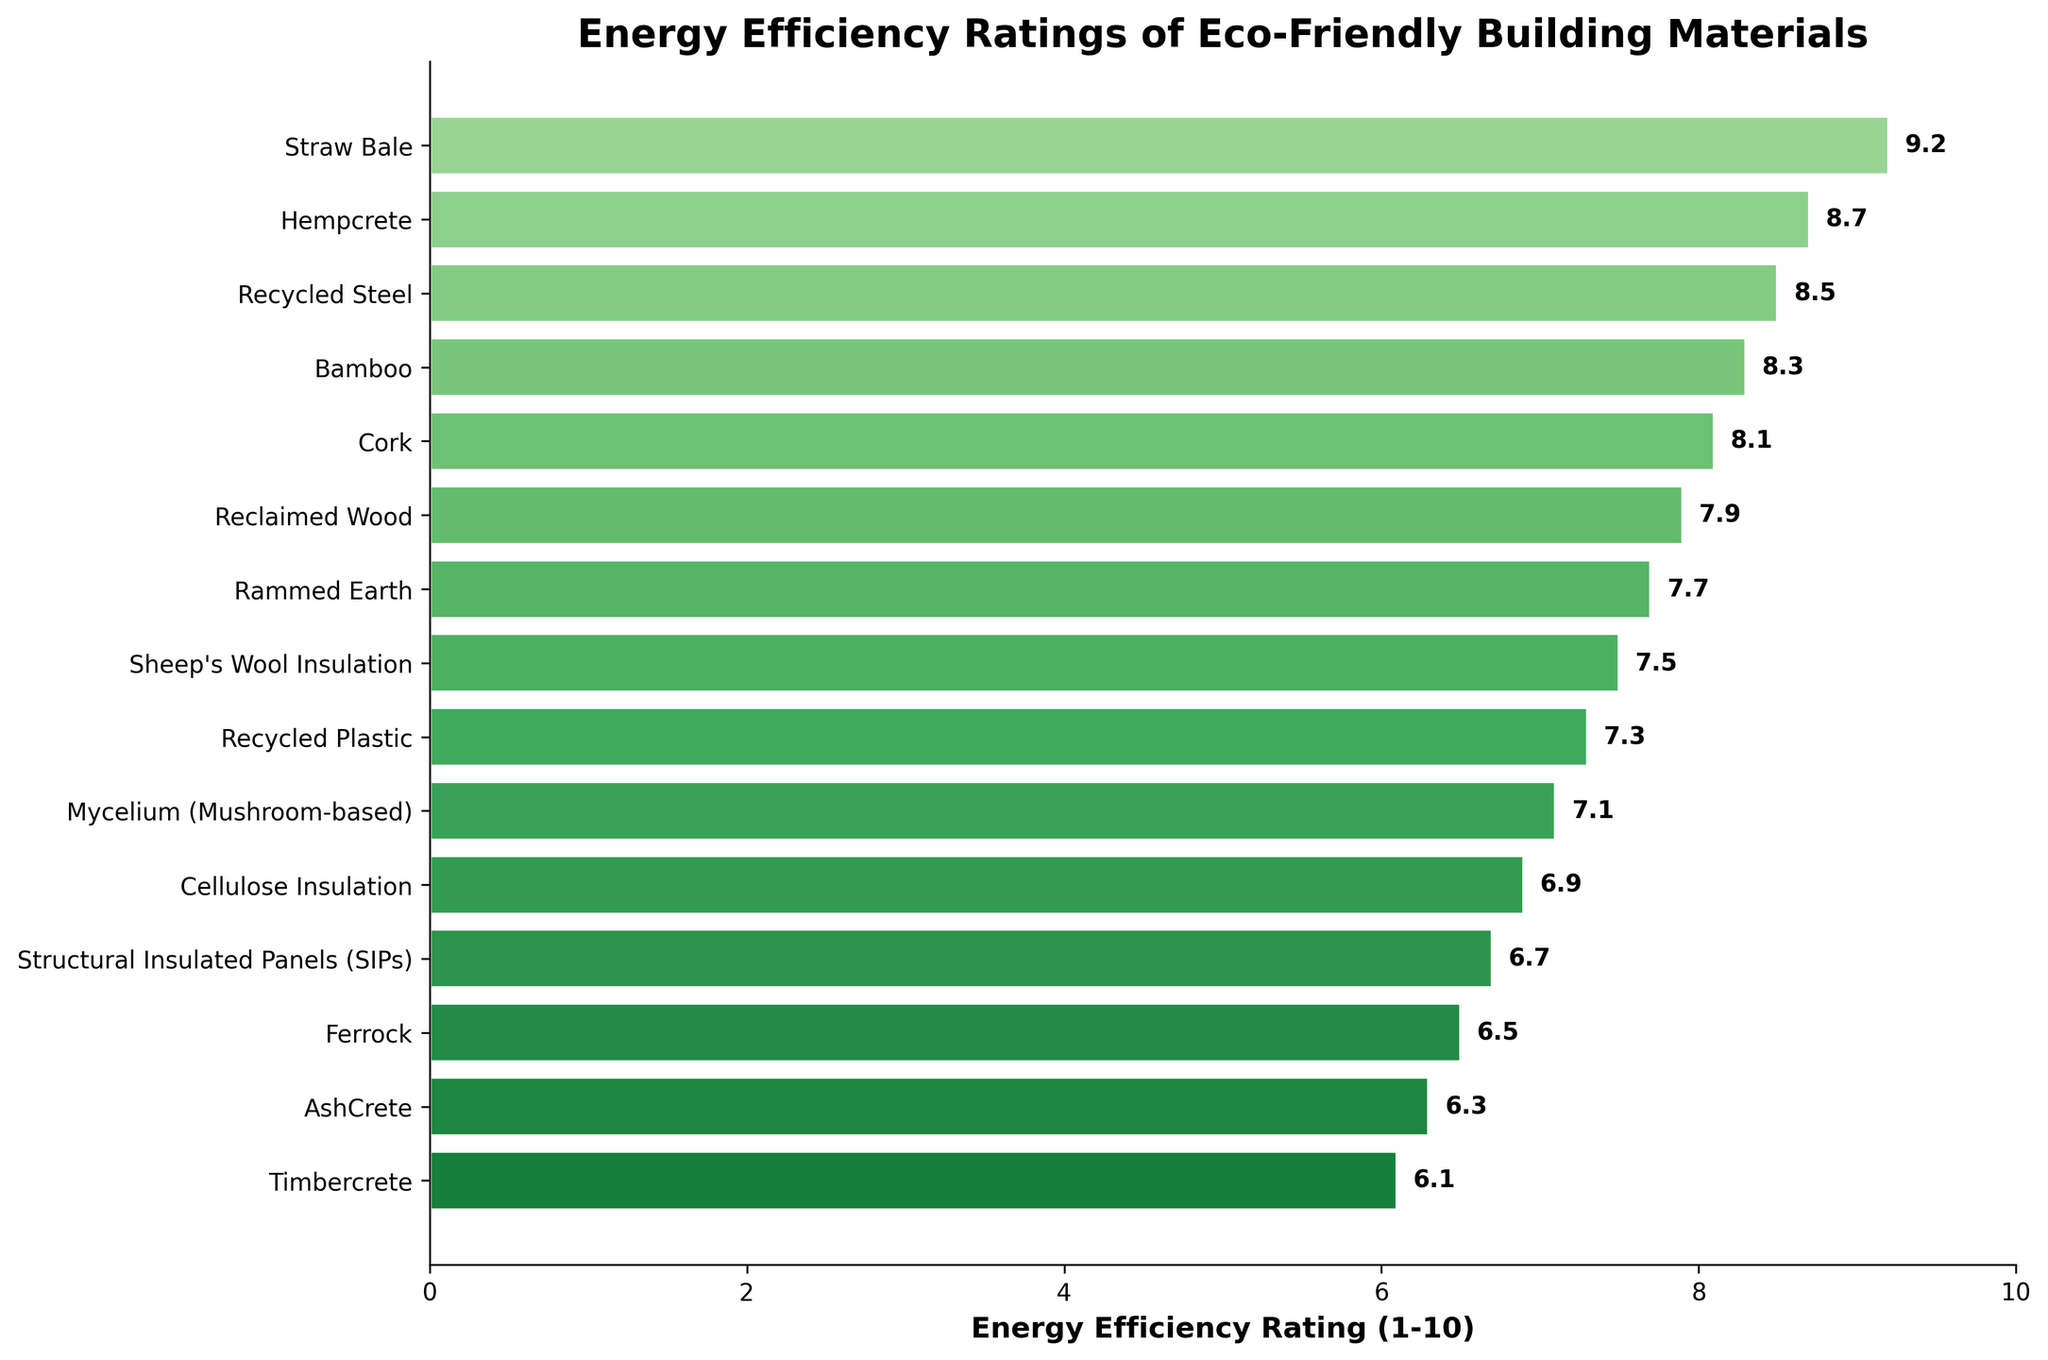What's the most energy-efficient building material? The highest energy efficiency rating on the chart is 9.2, which corresponds to Straw Bale.
Answer: Straw Bale Which material has a higher energy efficiency rating, Bamboo or Cork? The rating for Bamboo is 8.3, and for Cork, it's 8.1, so Bamboo has a higher rating.
Answer: Bamboo What are the three least energy-efficient materials? Looking at the three lowest bars on the chart, we see Timbercrete (6.1), AshCrete (6.3), and Ferrock (6.5).
Answer: Timbercrete, AshCrete, Ferrock What's the difference in energy efficiency rating between Hempcrete and Recycled Steel? The rating for Hempcrete is 8.7, and for Recycled Steel, it's 8.5. The difference is 8.7 - 8.5 = 0.2.
Answer: 0.2 How many materials have an energy efficiency rating above 7.0? Count the bars with ratings above 7.0: Straw Bale, Hempcrete, Recycled Steel, Bamboo, Cork, Reclaimed Wood, Rammed Earth, and Sheep's Wool Insulation which makes 8 materials.
Answer: 8 What's the average energy efficiency rating of the materials listed? Sum all the ratings: (9.2 + 8.7 + 8.5 + 8.3 + 8.1 + 7.9 + 7.7 + 7.5 + 7.3 + 7.1 + 6.9 + 6.7 + 6.5 + 6.3 + 6.1) = 112.8 and divide by the number of materials (15), so 112.8 / 15 = 7.52.
Answer: 7.52 Which material is directly in the middle of the energy efficiency ratings when sorted from highest to lowest? The 8th material in the list of 15 sorted materials is Sheep's Wool Insulation, with a rating of 7.5.
Answer: Sheep's Wool Insulation What’s the cumulative energy efficiency rating of the top 5 materials? Sum the ratings of the top 5 materials: (Straw Bale: 9.2 + Hempcrete: 8.7 + Recycled Steel: 8.5 + Bamboo: 8.3 + Cork: 8.1) = 42.8.
Answer: 42.8 By how much does Reclaimed Wood’s energy efficiency rating differ from Structural Insulated Panels (SIPs)? The rating for Reclaimed Wood is 7.9, and for SIPs, it's 6.7. The difference is 7.9 - 6.7 = 1.2.
Answer: 1.2 Which material has the closest energy efficiency rating to the average of all materials? The average is 7.52. The closest ratings are Sheep's Wool Insulation at 7.5 and Reclaimed Wood at 7.9, with Sheep's Wool Insulation being the closest.
Answer: Sheep's Wool Insulation 